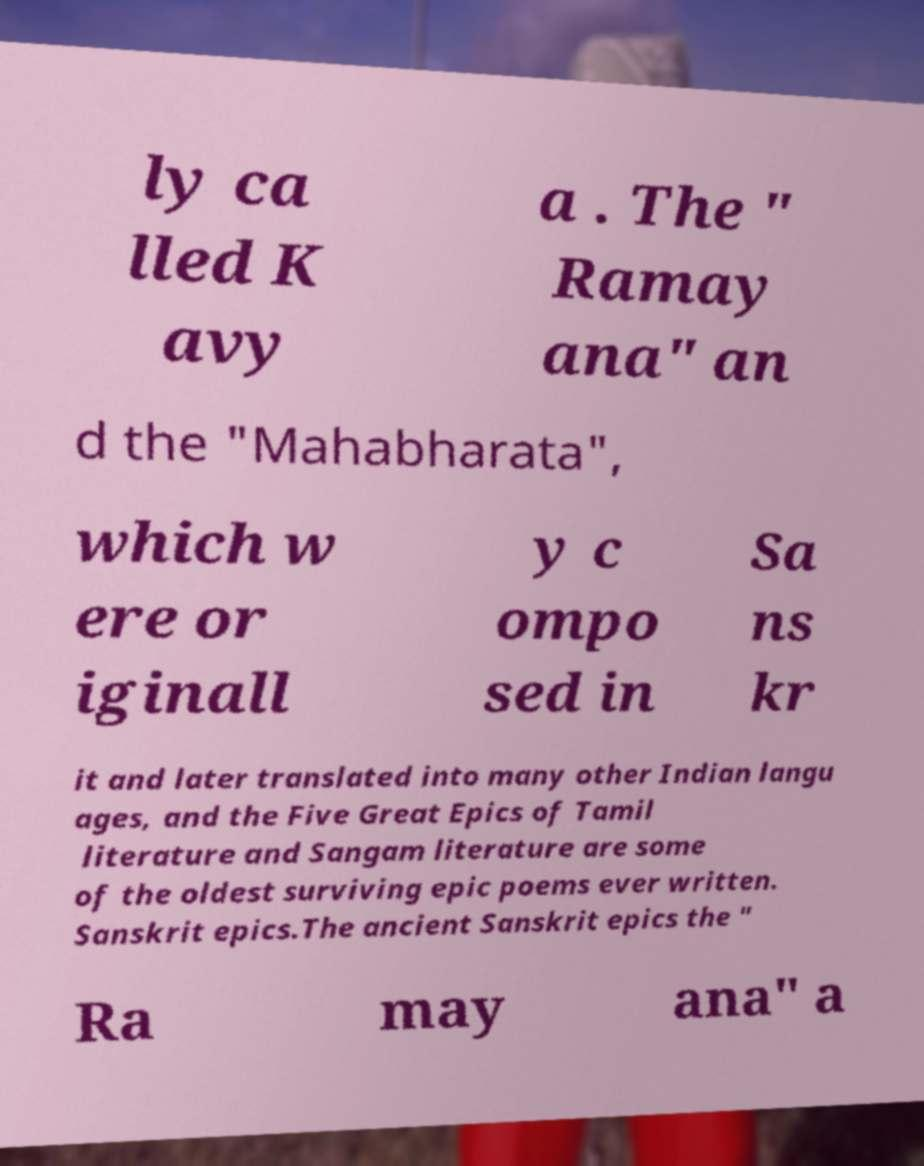Please read and relay the text visible in this image. What does it say? ly ca lled K avy a . The " Ramay ana" an d the "Mahabharata", which w ere or iginall y c ompo sed in Sa ns kr it and later translated into many other Indian langu ages, and the Five Great Epics of Tamil literature and Sangam literature are some of the oldest surviving epic poems ever written. Sanskrit epics.The ancient Sanskrit epics the " Ra may ana" a 